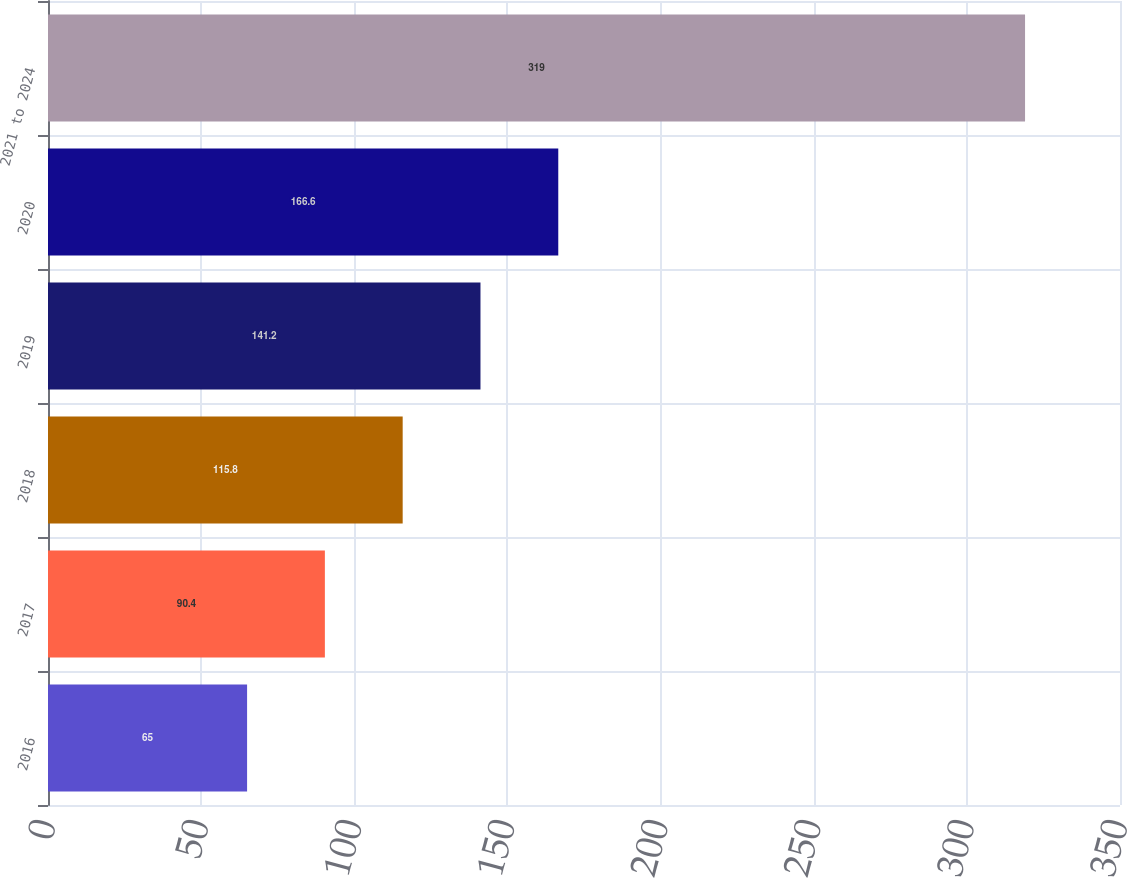Convert chart. <chart><loc_0><loc_0><loc_500><loc_500><bar_chart><fcel>2016<fcel>2017<fcel>2018<fcel>2019<fcel>2020<fcel>2021 to 2024<nl><fcel>65<fcel>90.4<fcel>115.8<fcel>141.2<fcel>166.6<fcel>319<nl></chart> 